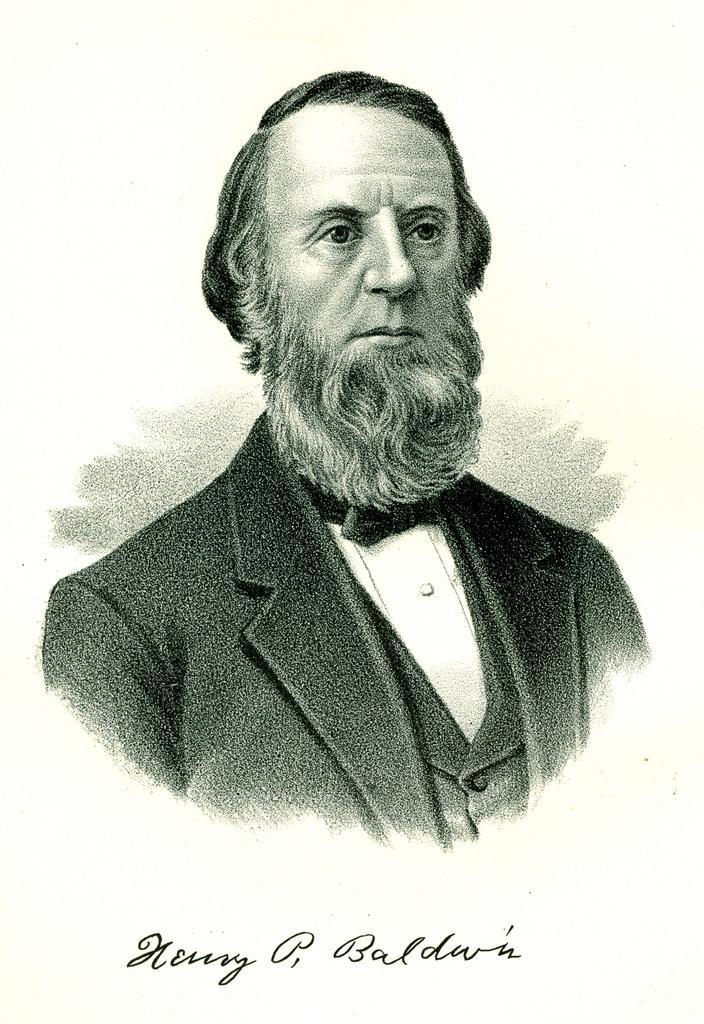Describe this image in one or two sentences. In this picture we can see a photo of a man. On the photo, it is written something. 